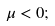Convert formula to latex. <formula><loc_0><loc_0><loc_500><loc_500>\mu < 0 ;</formula> 